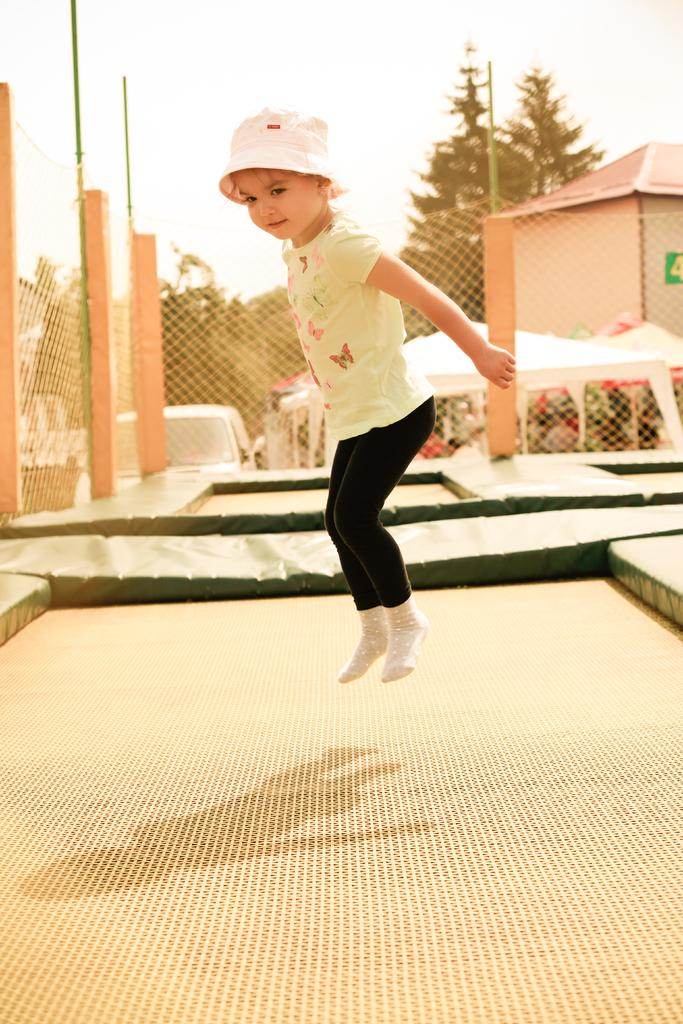Who is the main subject in the image? There is a girl in the image. What is the girl doing in the image? The girl is jumping. What can be seen in the image besides the girl? There are nets, a fence, and poles in the image. What is visible in the background of the image? In the background of the image, there are tents, a house, trees, and the sky. What type of clam can be seen in the image? There are no clams present in the image. How does the snow affect the girl's ability to jump in the image? There is no snow present in the image, so it does not affect the girl's ability to jump. 